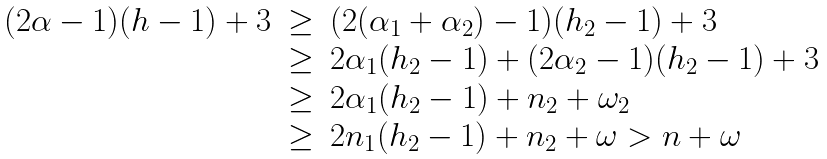Convert formula to latex. <formula><loc_0><loc_0><loc_500><loc_500>\begin{array} { r c l } ( 2 \alpha - 1 ) ( h - 1 ) + 3 & \geq & ( 2 ( \alpha _ { 1 } + \alpha _ { 2 } ) - 1 ) ( h _ { 2 } - 1 ) + 3 \\ & \geq & 2 \alpha _ { 1 } ( h _ { 2 } - 1 ) + ( 2 \alpha _ { 2 } - 1 ) ( h _ { 2 } - 1 ) + 3 \\ & \geq & 2 \alpha _ { 1 } ( h _ { 2 } - 1 ) + n _ { 2 } + \omega _ { 2 } \\ & \geq & 2 n _ { 1 } ( h _ { 2 } - 1 ) + n _ { 2 } + \omega > n + \omega \end{array}</formula> 